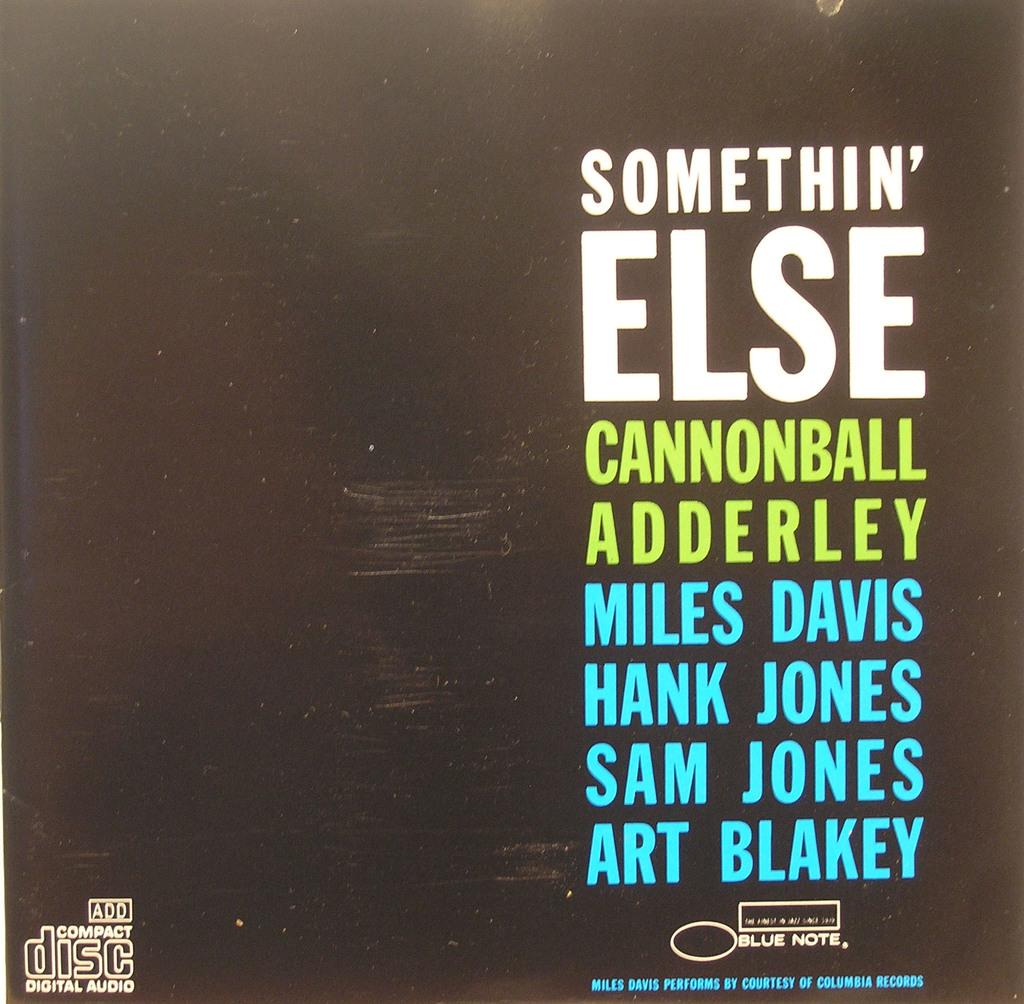Who is the third man on the list?
Provide a succinct answer. Sam jones. What is the name of this album?
Keep it short and to the point. Somethin' else. 